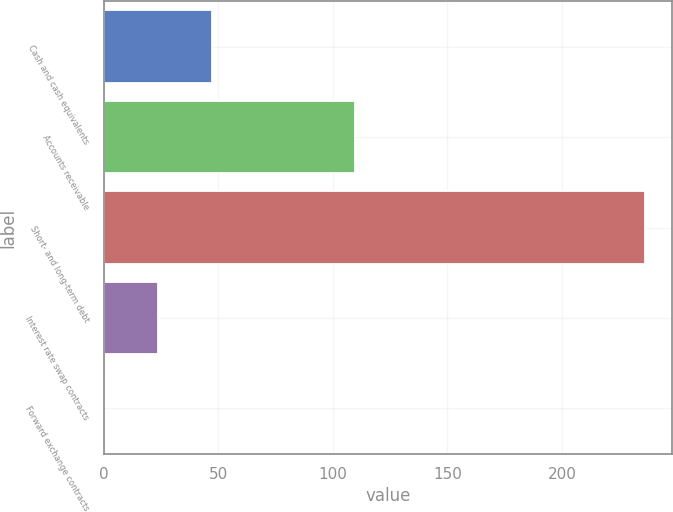Convert chart to OTSL. <chart><loc_0><loc_0><loc_500><loc_500><bar_chart><fcel>Cash and cash equivalents<fcel>Accounts receivable<fcel>Short- and long-term debt<fcel>Interest rate swap contracts<fcel>Forward exchange contracts<nl><fcel>47.34<fcel>109.5<fcel>236.3<fcel>23.72<fcel>0.1<nl></chart> 